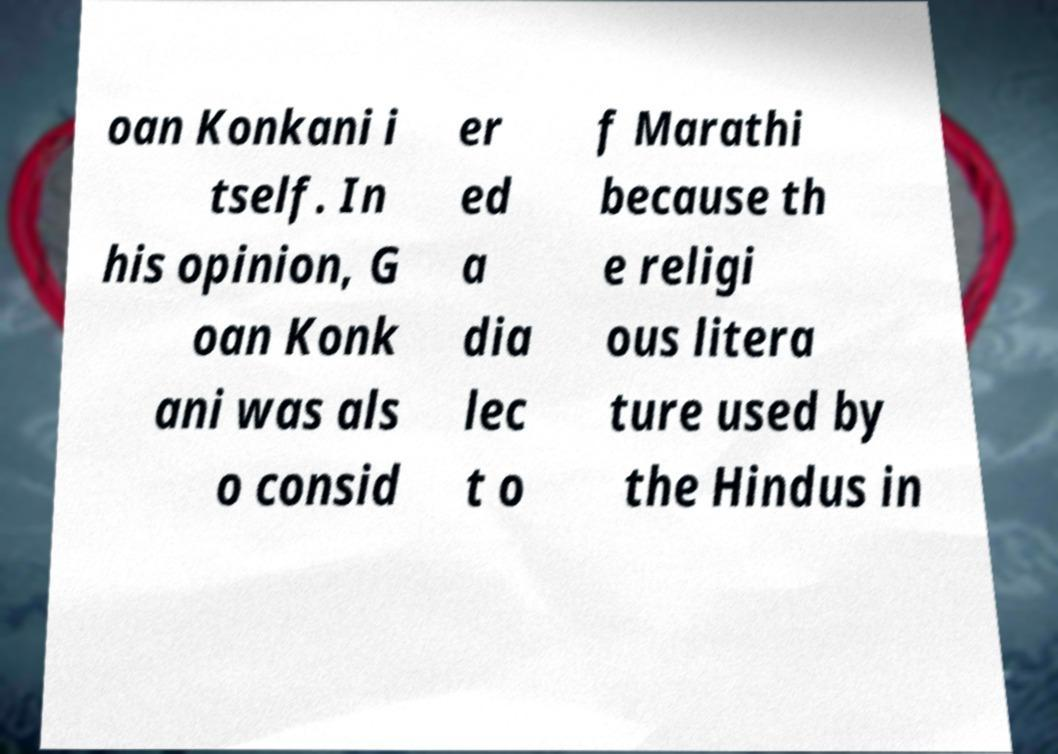Could you assist in decoding the text presented in this image and type it out clearly? oan Konkani i tself. In his opinion, G oan Konk ani was als o consid er ed a dia lec t o f Marathi because th e religi ous litera ture used by the Hindus in 